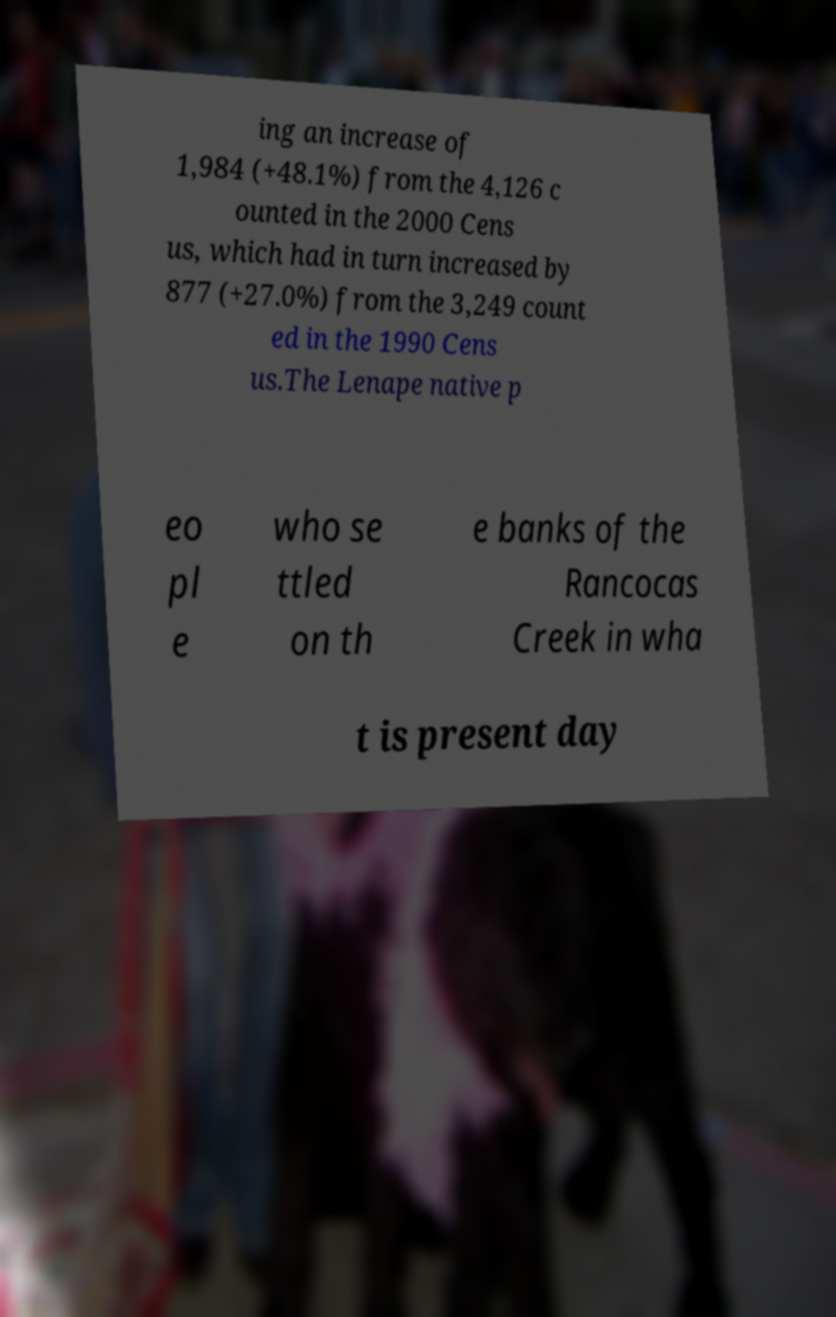Can you accurately transcribe the text from the provided image for me? ing an increase of 1,984 (+48.1%) from the 4,126 c ounted in the 2000 Cens us, which had in turn increased by 877 (+27.0%) from the 3,249 count ed in the 1990 Cens us.The Lenape native p eo pl e who se ttled on th e banks of the Rancocas Creek in wha t is present day 